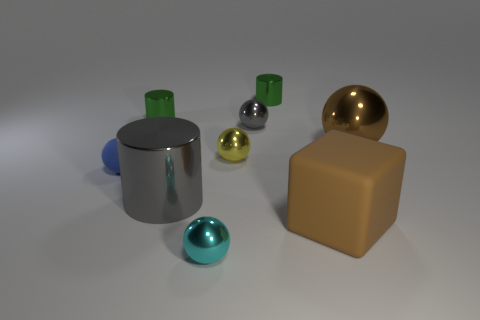What material is the large thing that is the same color as the cube?
Offer a terse response. Metal. What is the object that is both in front of the large gray metallic cylinder and on the left side of the big brown block made of?
Make the answer very short. Metal. There is a small blue thing that is the same shape as the small cyan thing; what material is it?
Offer a terse response. Rubber. What number of objects are either objects behind the large gray shiny object or big objects that are left of the small gray ball?
Keep it short and to the point. 7. Does the small rubber object have the same shape as the gray thing that is in front of the tiny gray ball?
Keep it short and to the point. No. What shape is the small green metal thing on the right side of the green metallic object that is on the left side of the small metallic sphere in front of the blue rubber ball?
Give a very brief answer. Cylinder. What number of other things are there of the same material as the large cube
Make the answer very short. 1. How many objects are balls that are in front of the big brown ball or brown metallic spheres?
Your response must be concise. 4. There is a matte object behind the rubber object that is in front of the large gray thing; what shape is it?
Keep it short and to the point. Sphere. Does the big metal thing right of the big rubber block have the same shape as the cyan object?
Make the answer very short. Yes. 